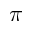Convert formula to latex. <formula><loc_0><loc_0><loc_500><loc_500>\pi</formula> 